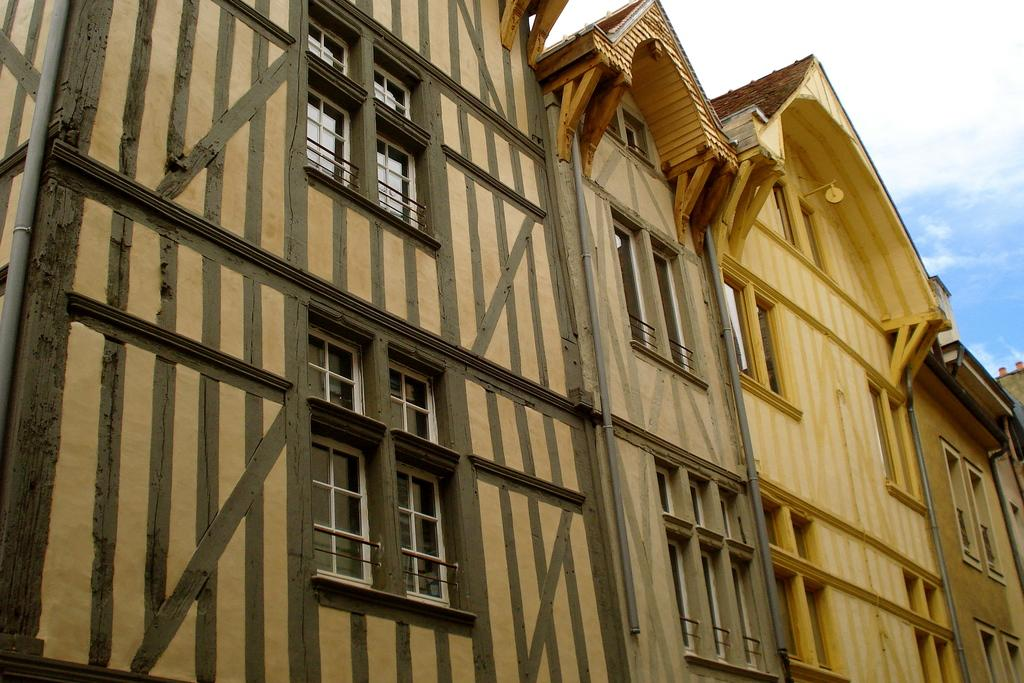What type of structures can be seen in the image? There are buildings in the image. What part of the natural environment is visible in the image? The sky is visible in the image. Can you describe the sky in the image? The sky appears to be cloudy in the image. Where is the amusement park located in the image? There is no amusement park present in the image. What type of fan can be seen in the image? There is no fan present in the image. 